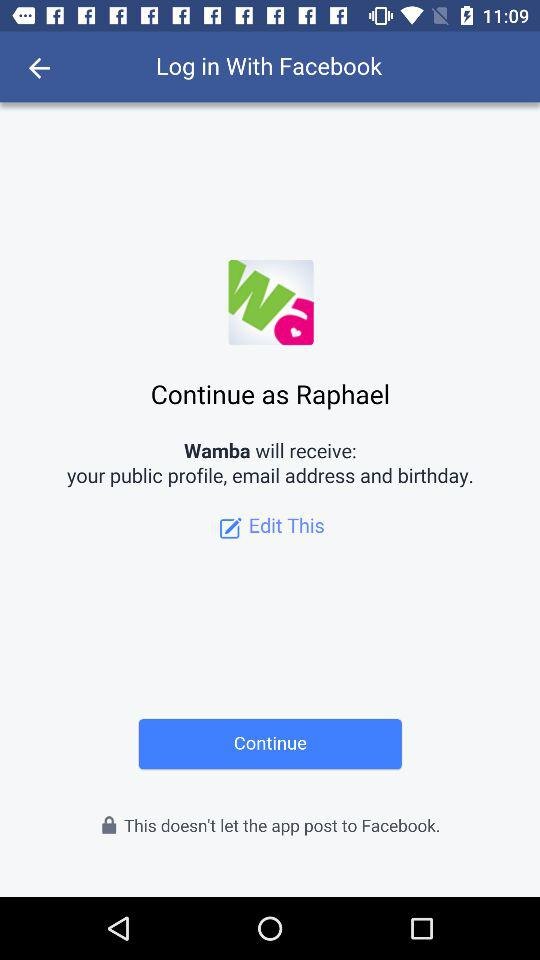Through what application can we log in? You can log in through "Facebook". 